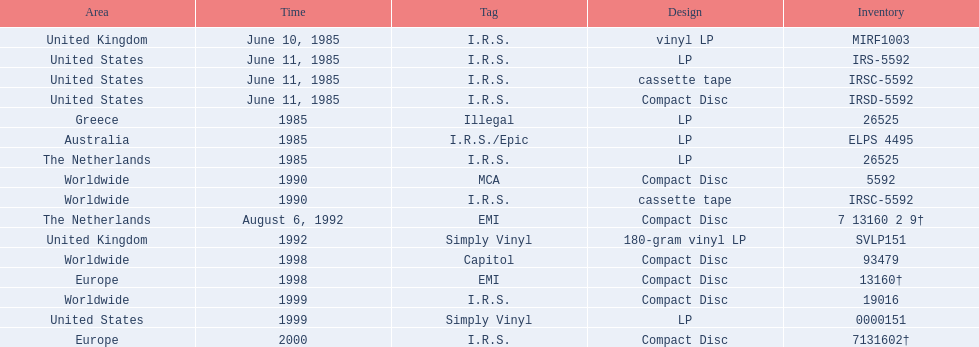What dates were lps of any kind released? June 10, 1985, June 11, 1985, 1985, 1985, 1985, 1992, 1999. In which countries were these released in by i.r.s.? United Kingdom, United States, Australia, The Netherlands. Which of these countries is not in the northern hemisphere? Australia. 